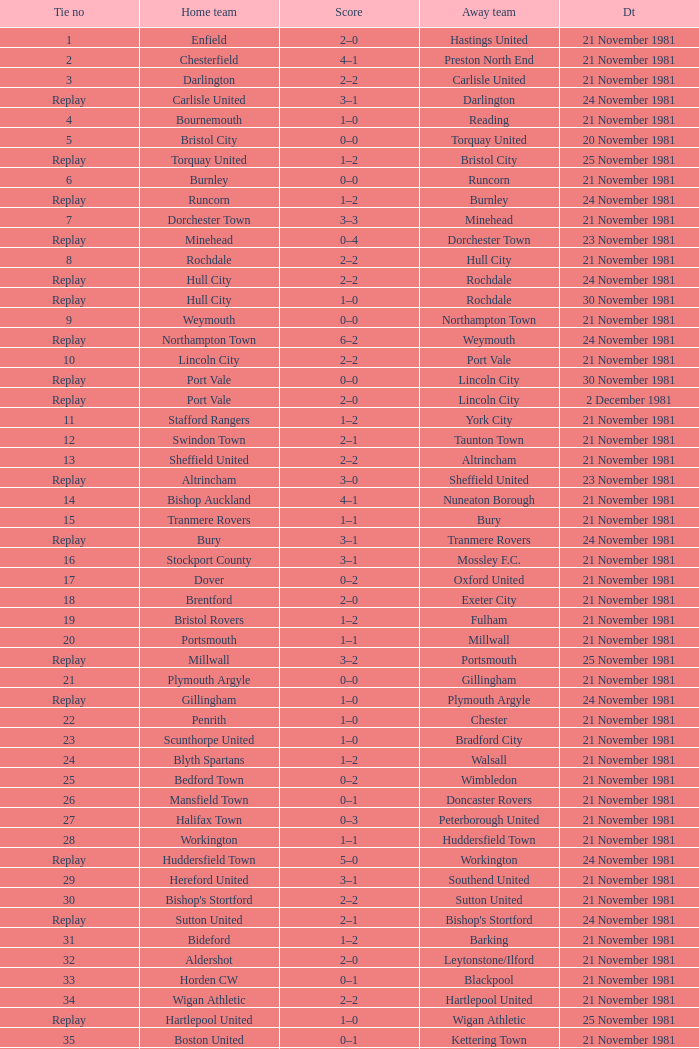What is enfield's tie number? 1.0. 